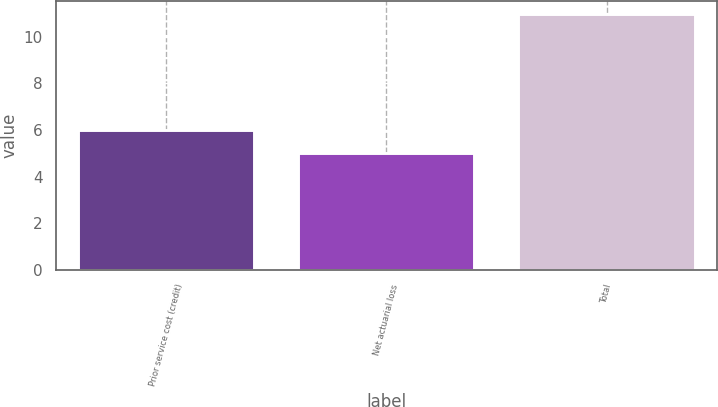<chart> <loc_0><loc_0><loc_500><loc_500><bar_chart><fcel>Prior service cost (credit)<fcel>Net actuarial loss<fcel>Total<nl><fcel>6<fcel>5<fcel>11<nl></chart> 